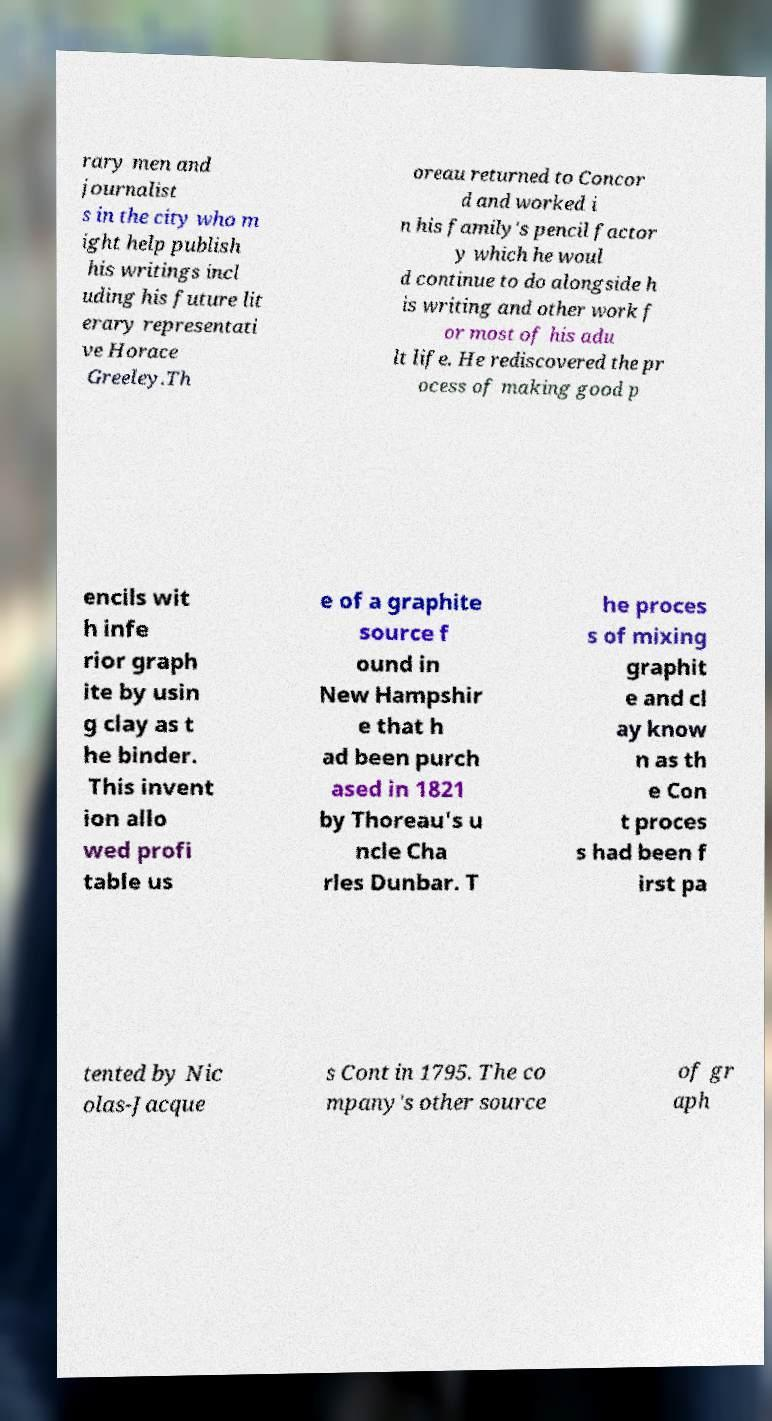Please identify and transcribe the text found in this image. rary men and journalist s in the city who m ight help publish his writings incl uding his future lit erary representati ve Horace Greeley.Th oreau returned to Concor d and worked i n his family's pencil factor y which he woul d continue to do alongside h is writing and other work f or most of his adu lt life. He rediscovered the pr ocess of making good p encils wit h infe rior graph ite by usin g clay as t he binder. This invent ion allo wed profi table us e of a graphite source f ound in New Hampshir e that h ad been purch ased in 1821 by Thoreau's u ncle Cha rles Dunbar. T he proces s of mixing graphit e and cl ay know n as th e Con t proces s had been f irst pa tented by Nic olas-Jacque s Cont in 1795. The co mpany's other source of gr aph 